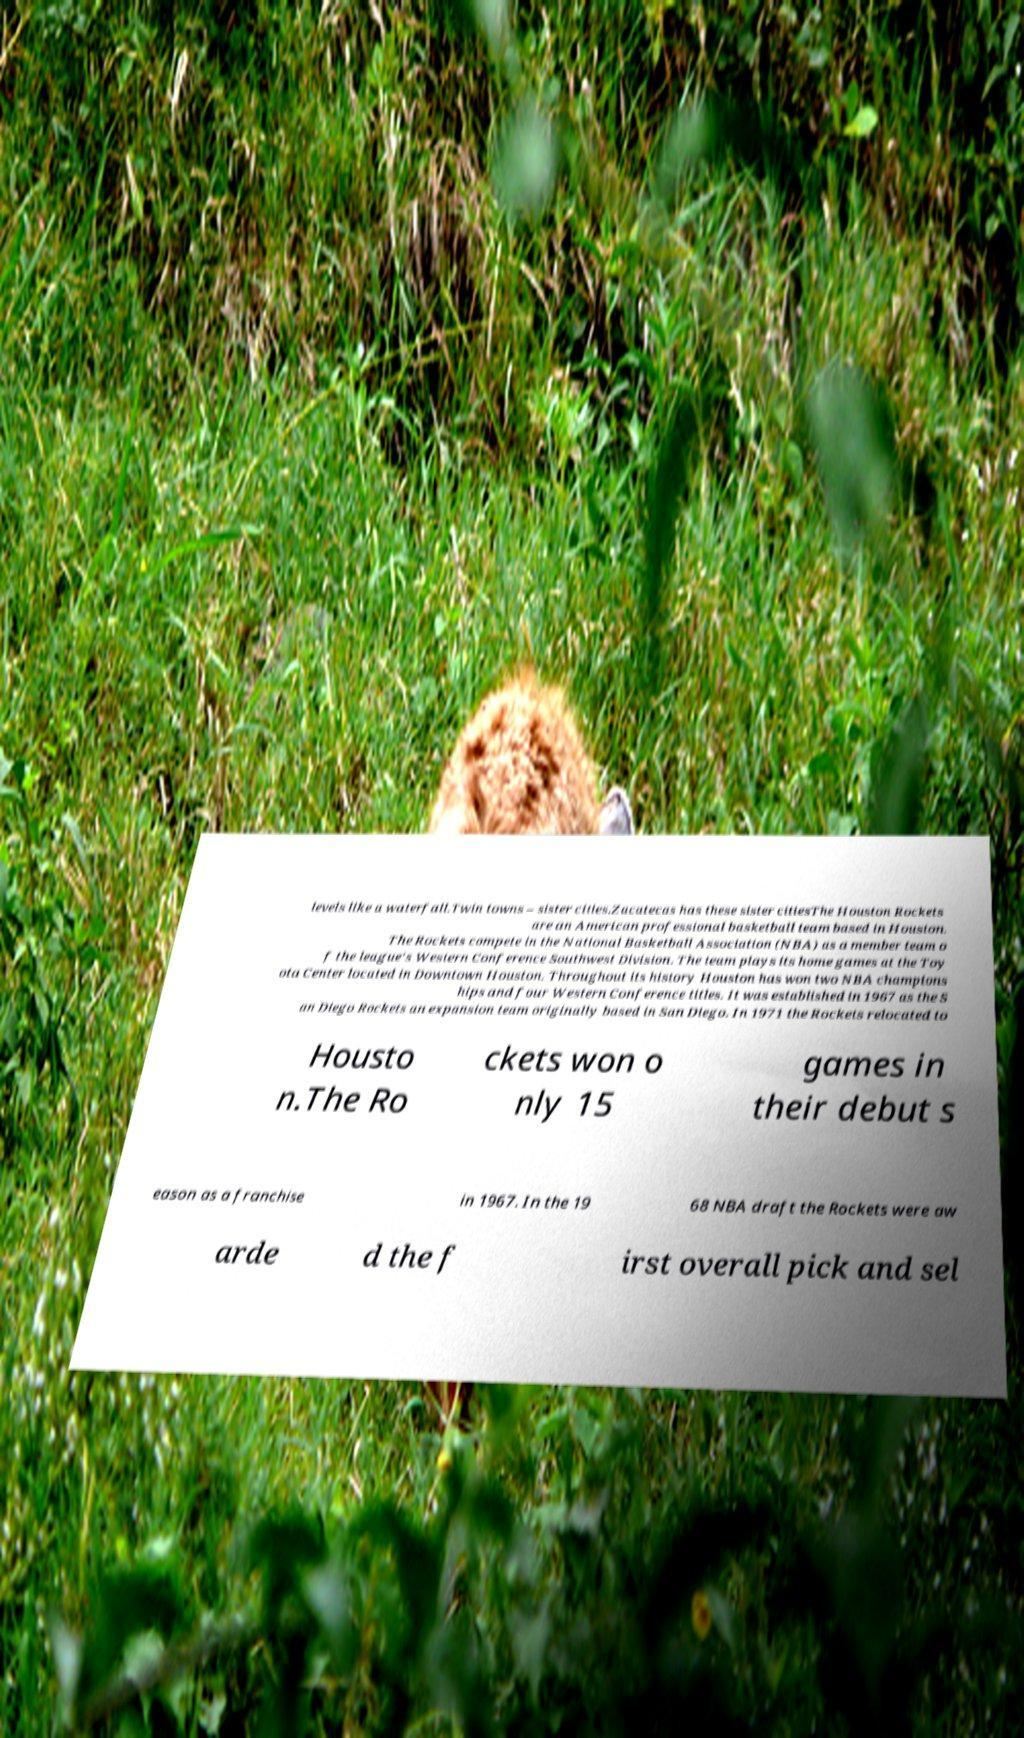What messages or text are displayed in this image? I need them in a readable, typed format. levels like a waterfall.Twin towns – sister cities.Zacatecas has these sister citiesThe Houston Rockets are an American professional basketball team based in Houston. The Rockets compete in the National Basketball Association (NBA) as a member team o f the league's Western Conference Southwest Division. The team plays its home games at the Toy ota Center located in Downtown Houston. Throughout its history Houston has won two NBA champions hips and four Western Conference titles. It was established in 1967 as the S an Diego Rockets an expansion team originally based in San Diego. In 1971 the Rockets relocated to Housto n.The Ro ckets won o nly 15 games in their debut s eason as a franchise in 1967. In the 19 68 NBA draft the Rockets were aw arde d the f irst overall pick and sel 